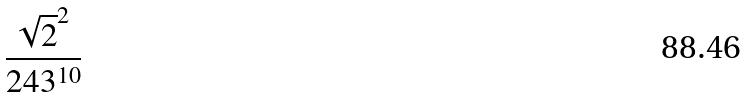<formula> <loc_0><loc_0><loc_500><loc_500>\frac { \sqrt { 2 } ^ { 2 } } { 2 4 3 ^ { 1 0 } }</formula> 